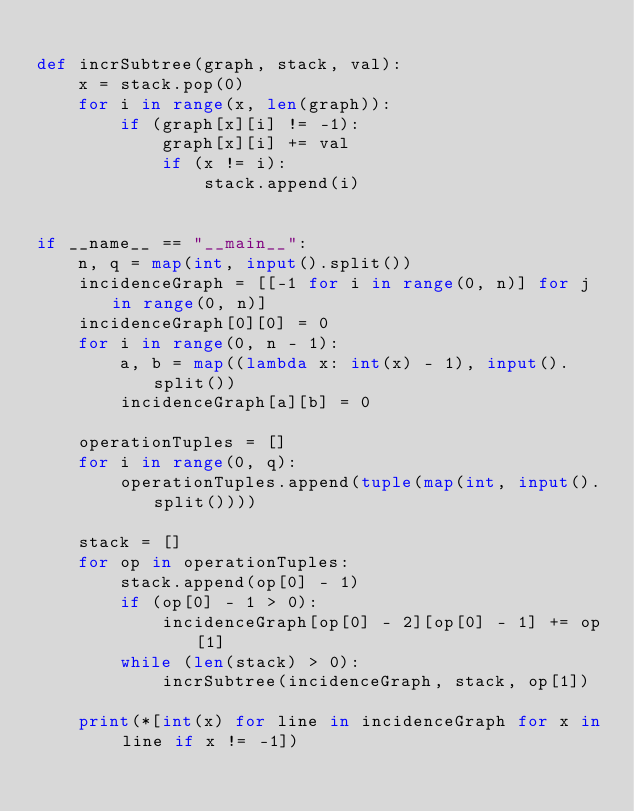Convert code to text. <code><loc_0><loc_0><loc_500><loc_500><_Python_>
def incrSubtree(graph, stack, val):
    x = stack.pop(0)
    for i in range(x, len(graph)):
        if (graph[x][i] != -1):
            graph[x][i] += val
            if (x != i):
                stack.append(i)


if __name__ == "__main__":
    n, q = map(int, input().split())
    incidenceGraph = [[-1 for i in range(0, n)] for j in range(0, n)]
    incidenceGraph[0][0] = 0
    for i in range(0, n - 1):
        a, b = map((lambda x: int(x) - 1), input().split())
        incidenceGraph[a][b] = 0

    operationTuples = []
    for i in range(0, q):
        operationTuples.append(tuple(map(int, input().split())))

    stack = []
    for op in operationTuples:
        stack.append(op[0] - 1)
        if (op[0] - 1 > 0):
            incidenceGraph[op[0] - 2][op[0] - 1] += op[1]
        while (len(stack) > 0):
            incrSubtree(incidenceGraph, stack, op[1])

    print(*[int(x) for line in incidenceGraph for x in line if x != -1])
</code> 